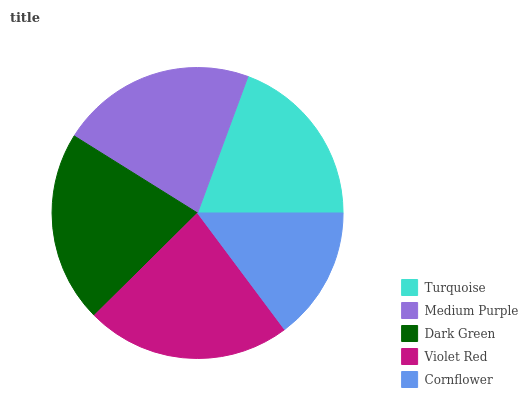Is Cornflower the minimum?
Answer yes or no. Yes. Is Violet Red the maximum?
Answer yes or no. Yes. Is Medium Purple the minimum?
Answer yes or no. No. Is Medium Purple the maximum?
Answer yes or no. No. Is Medium Purple greater than Turquoise?
Answer yes or no. Yes. Is Turquoise less than Medium Purple?
Answer yes or no. Yes. Is Turquoise greater than Medium Purple?
Answer yes or no. No. Is Medium Purple less than Turquoise?
Answer yes or no. No. Is Dark Green the high median?
Answer yes or no. Yes. Is Dark Green the low median?
Answer yes or no. Yes. Is Turquoise the high median?
Answer yes or no. No. Is Medium Purple the low median?
Answer yes or no. No. 